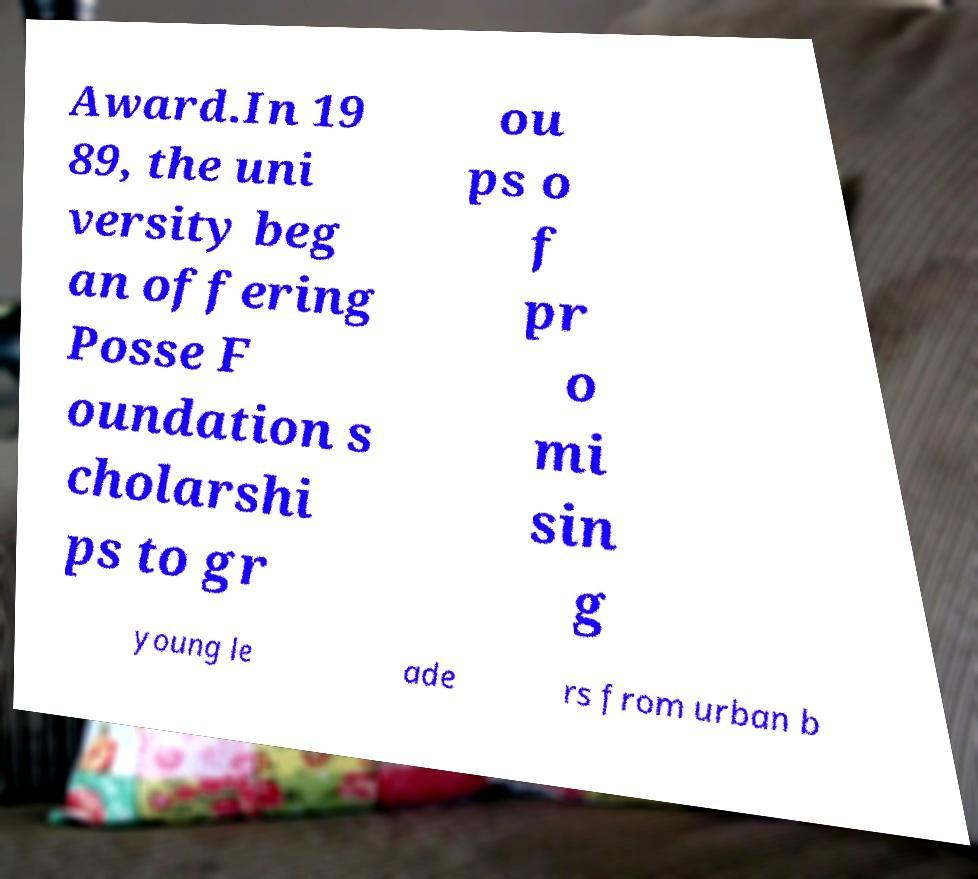There's text embedded in this image that I need extracted. Can you transcribe it verbatim? Award.In 19 89, the uni versity beg an offering Posse F oundation s cholarshi ps to gr ou ps o f pr o mi sin g young le ade rs from urban b 